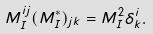<formula> <loc_0><loc_0><loc_500><loc_500>M _ { I } ^ { i j } ( M _ { I } ^ { * } ) _ { j k } = M _ { I } ^ { 2 } \delta _ { k } ^ { i } .</formula> 